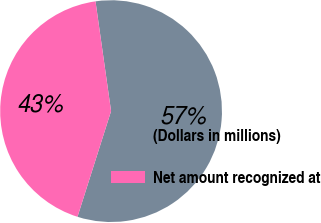<chart> <loc_0><loc_0><loc_500><loc_500><pie_chart><fcel>(Dollars in millions)<fcel>Net amount recognized at<nl><fcel>57.14%<fcel>42.86%<nl></chart> 